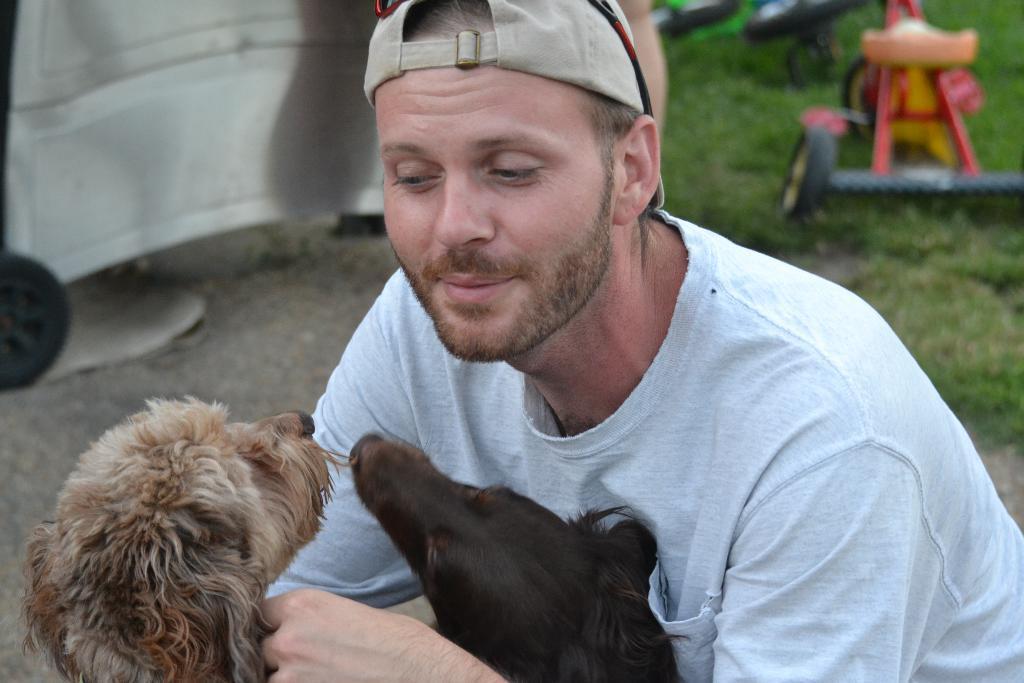Can you describe this image briefly? There is a man in the picture wearing a white T-shirt. He's holding two puppies here in his hands. In the background there is a cycle. 